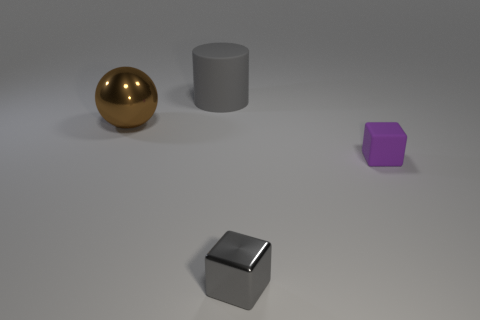Subtract all gray blocks. How many blocks are left? 1 Add 3 small metallic blocks. How many objects exist? 7 Subtract all cylinders. How many objects are left? 3 Subtract 1 blocks. How many blocks are left? 1 Subtract all blue spheres. How many purple blocks are left? 1 Subtract all small gray metallic blocks. Subtract all small matte things. How many objects are left? 2 Add 1 small gray shiny blocks. How many small gray shiny blocks are left? 2 Add 3 big objects. How many big objects exist? 5 Subtract 1 purple blocks. How many objects are left? 3 Subtract all purple spheres. Subtract all green blocks. How many spheres are left? 1 